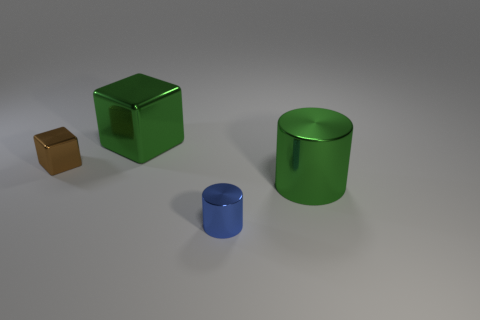Is there any other thing that is the same color as the large cylinder?
Give a very brief answer. Yes. There is a large cylinder; does it have the same color as the large thing left of the large cylinder?
Give a very brief answer. Yes. What is the shape of the object that is both in front of the brown metallic thing and behind the blue metallic cylinder?
Ensure brevity in your answer.  Cylinder. Are there any blocks that have the same color as the big metallic cylinder?
Keep it short and to the point. Yes. What number of green shiny things have the same shape as the small brown thing?
Your response must be concise. 1. The tiny brown metallic object is what shape?
Give a very brief answer. Cube. Are there fewer big cylinders than cylinders?
Make the answer very short. Yes. There is another object that is the same shape as the brown object; what material is it?
Make the answer very short. Metal. Is the number of green things greater than the number of tiny purple shiny objects?
Your response must be concise. Yes. How many other objects are the same color as the small cube?
Ensure brevity in your answer.  0. 